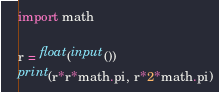Convert code to text. <code><loc_0><loc_0><loc_500><loc_500><_Python_>import math

r = float(input())
print(r*r*math.pi, r*2*math.pi)
</code> 